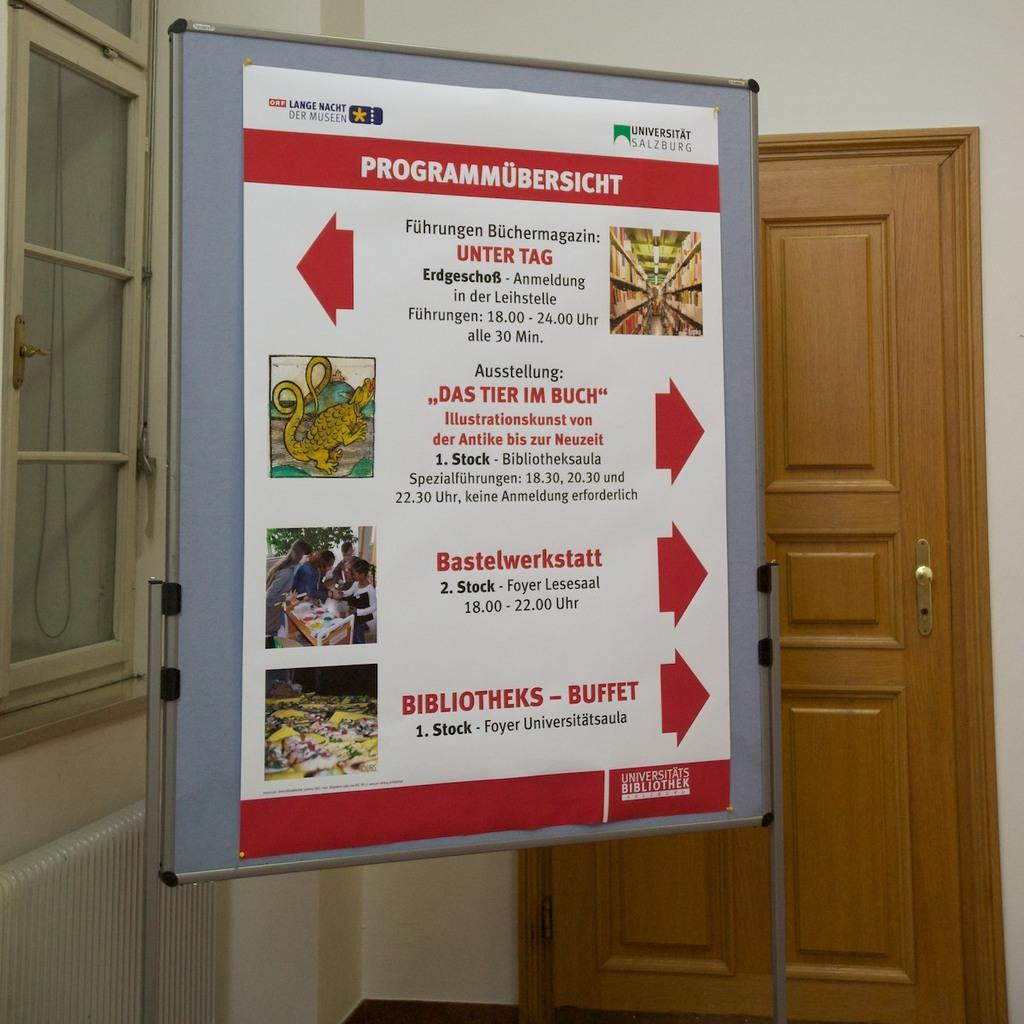<image>
Render a clear and concise summary of the photo. Programmubersicht sign for the universitats bibliothek on a board in a room 